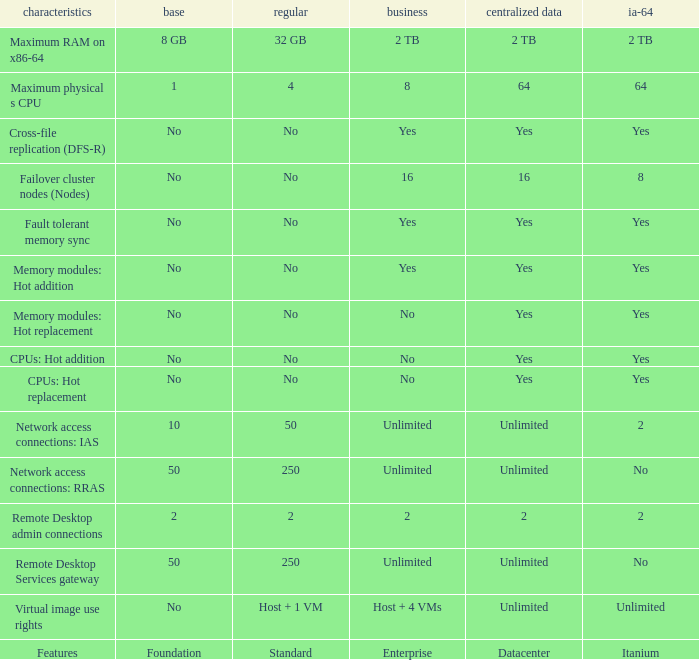Which Foundation has an Enterprise of 2? 2.0. Can you give me this table as a dict? {'header': ['characteristics', 'base', 'regular', 'business', 'centralized data', 'ia-64'], 'rows': [['Maximum RAM on x86-64', '8 GB', '32 GB', '2 TB', '2 TB', '2 TB'], ['Maximum physical s CPU', '1', '4', '8', '64', '64'], ['Cross-file replication (DFS-R)', 'No', 'No', 'Yes', 'Yes', 'Yes'], ['Failover cluster nodes (Nodes)', 'No', 'No', '16', '16', '8'], ['Fault tolerant memory sync', 'No', 'No', 'Yes', 'Yes', 'Yes'], ['Memory modules: Hot addition', 'No', 'No', 'Yes', 'Yes', 'Yes'], ['Memory modules: Hot replacement', 'No', 'No', 'No', 'Yes', 'Yes'], ['CPUs: Hot addition', 'No', 'No', 'No', 'Yes', 'Yes'], ['CPUs: Hot replacement', 'No', 'No', 'No', 'Yes', 'Yes'], ['Network access connections: IAS', '10', '50', 'Unlimited', 'Unlimited', '2'], ['Network access connections: RRAS', '50', '250', 'Unlimited', 'Unlimited', 'No'], ['Remote Desktop admin connections', '2', '2', '2', '2', '2'], ['Remote Desktop Services gateway', '50', '250', 'Unlimited', 'Unlimited', 'No'], ['Virtual image use rights', 'No', 'Host + 1 VM', 'Host + 4 VMs', 'Unlimited', 'Unlimited'], ['Features', 'Foundation', 'Standard', 'Enterprise', 'Datacenter', 'Itanium']]} 